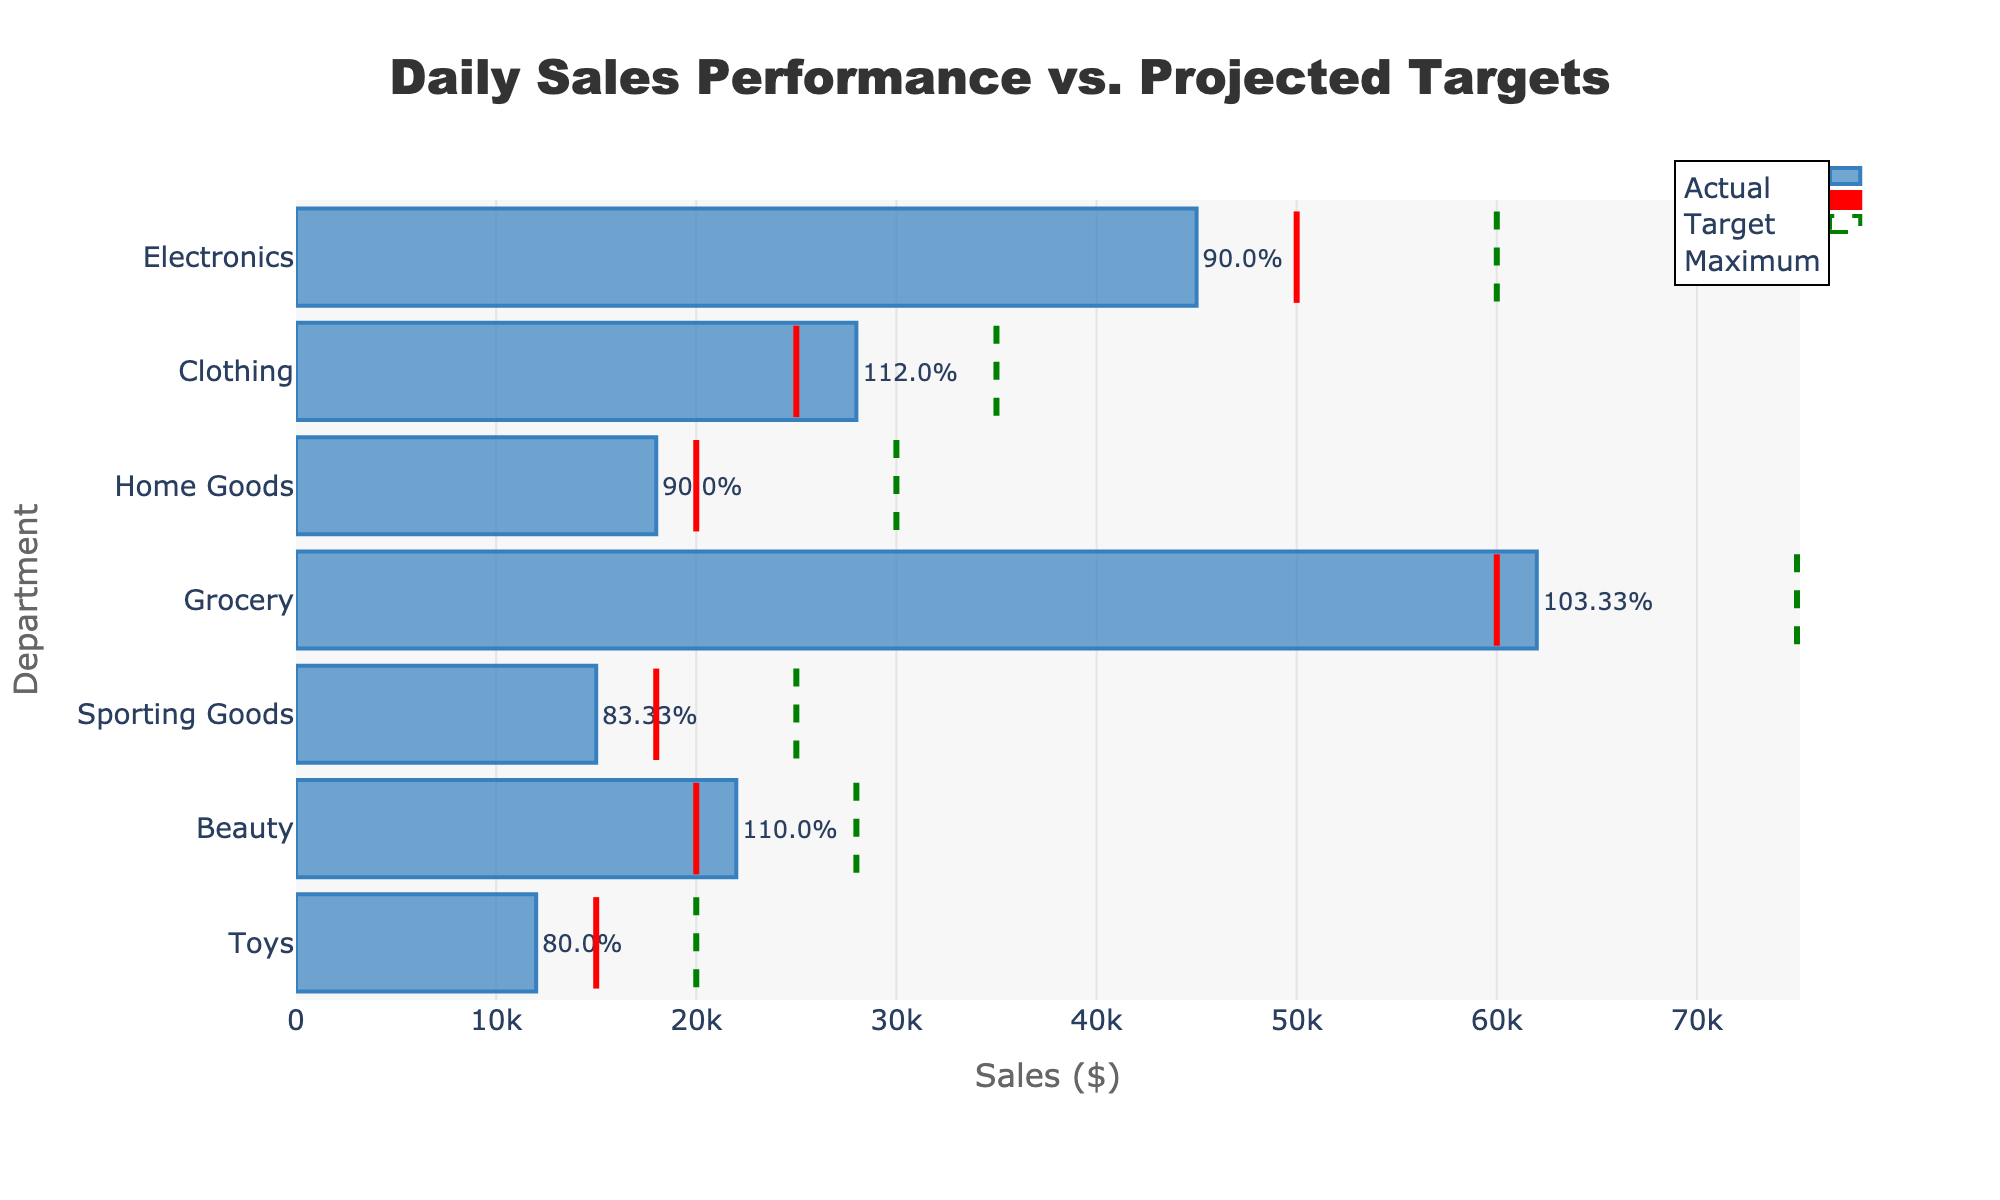Which department has the highest actual sales? The department with the highest actual sales can be identified by looking at the length of the blue bars. Grocery has the longest bar, indicating the highest actual sales.
Answer: Grocery What is the target sales value for the Electronics department? Find the red target line for the Electronics department, which intersects at the value of 50,000.
Answer: 50,000 How much did the Beauty department's actual sales exceed its target sales? The Beauty department has actual sales of 22,000 and a target of 20,000. Subtract the target sales from the actual sales: 22,000 - 20,000 = 2,000.
Answer: 2,000 Which department had the worst performance relative to its target sales? Performance can be interpreted as the percentage of the target achieved. Toys have a lower actual sales bar compared to their target with the smallest performance percentage (80%).
Answer: Toys Compare the actual sales of Clothing and Electronics departments, which one is higher and by how much? The actual sales for Clothing are 28,000 while for Electronics they are 45,000. Subtract Clothing's sales from Electronics': 45,000 - 28,000 = 17,000. Electronics has higher sales by 17,000.
Answer: Electronics, 17,000 What is the maximum sales projection for the Home Goods department? Look for the green dashed line in the Home Goods row, which marks the maximum sales value at 30,000.
Answer: 30,000 Calculate the total actual sales for all departments combined. Sum the actual sales values for all departments: 45,000 + 28,000 + 18,000 + 62,000 + 15,000 + 22,000 + 12,000 = 202,000.
Answer: 202,000 Which department achieved exactly their target sales? Compare actual sales and target sales for each department. The Grocery department achieved exactly their target sales of 60,000.
Answer: Grocery How do Home Goods' actual sales compare to their target sales? The actual sales for Home Goods are 18,000, and the target sales are 20,000. Subtract actual sales from target sales: 18,000 - 20,000 = -2,000, so they are below their target by 2,000.
Answer: Below by 2,000 Identify the department with the smallest difference between actual and maximum sales, and state that difference. Calculate the difference for each department:
- Electronics: 60,000 - 45,000 = 15,000
- Clothing: 35,000 - 28,000 = 7,000
- Home Goods: 30,000 - 18,000 = 12,000
- Grocery: 75,000 - 62,000 = 13,000
- Sporting Goods: 25,000 - 15,000 = 10,000
- Beauty: 28,000 - 22,000 = 6,000
- Toys: 20,000 - 12,000 = 8,000
Beauty has the smallest difference of 6,000.
Answer: Beauty, 6,000 